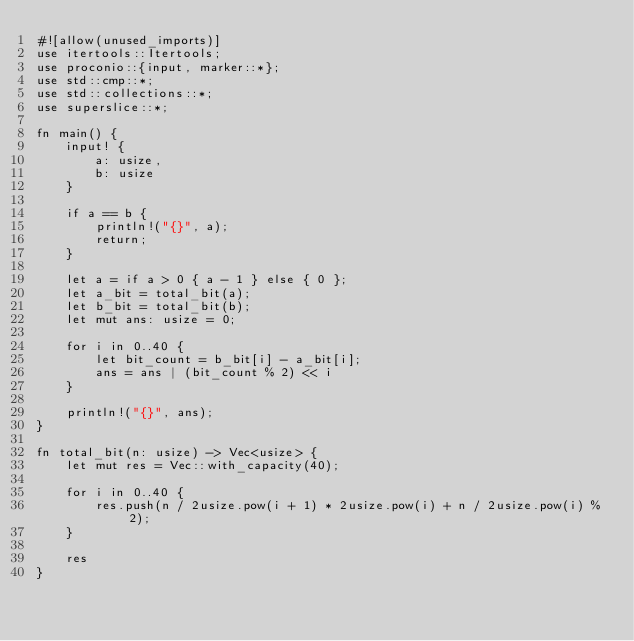Convert code to text. <code><loc_0><loc_0><loc_500><loc_500><_Rust_>#![allow(unused_imports)]
use itertools::Itertools;
use proconio::{input, marker::*};
use std::cmp::*;
use std::collections::*;
use superslice::*;

fn main() {
    input! {
        a: usize,
        b: usize
    }

    if a == b {
        println!("{}", a);
        return;
    }

    let a = if a > 0 { a - 1 } else { 0 };
    let a_bit = total_bit(a);
    let b_bit = total_bit(b);
    let mut ans: usize = 0;

    for i in 0..40 {
        let bit_count = b_bit[i] - a_bit[i];
        ans = ans | (bit_count % 2) << i
    }

    println!("{}", ans);
}

fn total_bit(n: usize) -> Vec<usize> {
    let mut res = Vec::with_capacity(40);

    for i in 0..40 {
        res.push(n / 2usize.pow(i + 1) * 2usize.pow(i) + n / 2usize.pow(i) % 2);
    }

    res
}
</code> 